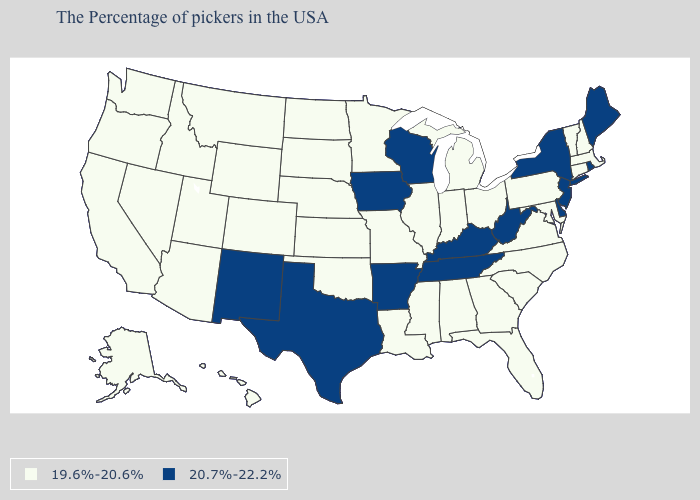Does New Hampshire have the highest value in the Northeast?
Keep it brief. No. Does Connecticut have a lower value than Iowa?
Write a very short answer. Yes. Is the legend a continuous bar?
Quick response, please. No. What is the value of Texas?
Quick response, please. 20.7%-22.2%. Which states hav the highest value in the MidWest?
Answer briefly. Wisconsin, Iowa. What is the value of Colorado?
Short answer required. 19.6%-20.6%. Which states hav the highest value in the Northeast?
Be succinct. Maine, Rhode Island, New York, New Jersey. Does Washington have the highest value in the USA?
Concise answer only. No. Does Maryland have the highest value in the USA?
Short answer required. No. Name the states that have a value in the range 19.6%-20.6%?
Answer briefly. Massachusetts, New Hampshire, Vermont, Connecticut, Maryland, Pennsylvania, Virginia, North Carolina, South Carolina, Ohio, Florida, Georgia, Michigan, Indiana, Alabama, Illinois, Mississippi, Louisiana, Missouri, Minnesota, Kansas, Nebraska, Oklahoma, South Dakota, North Dakota, Wyoming, Colorado, Utah, Montana, Arizona, Idaho, Nevada, California, Washington, Oregon, Alaska, Hawaii. Among the states that border Connecticut , does Massachusetts have the highest value?
Be succinct. No. What is the lowest value in states that border Alabama?
Keep it brief. 19.6%-20.6%. Among the states that border Arkansas , which have the highest value?
Short answer required. Tennessee, Texas. What is the lowest value in the Northeast?
Give a very brief answer. 19.6%-20.6%. What is the value of Connecticut?
Write a very short answer. 19.6%-20.6%. 